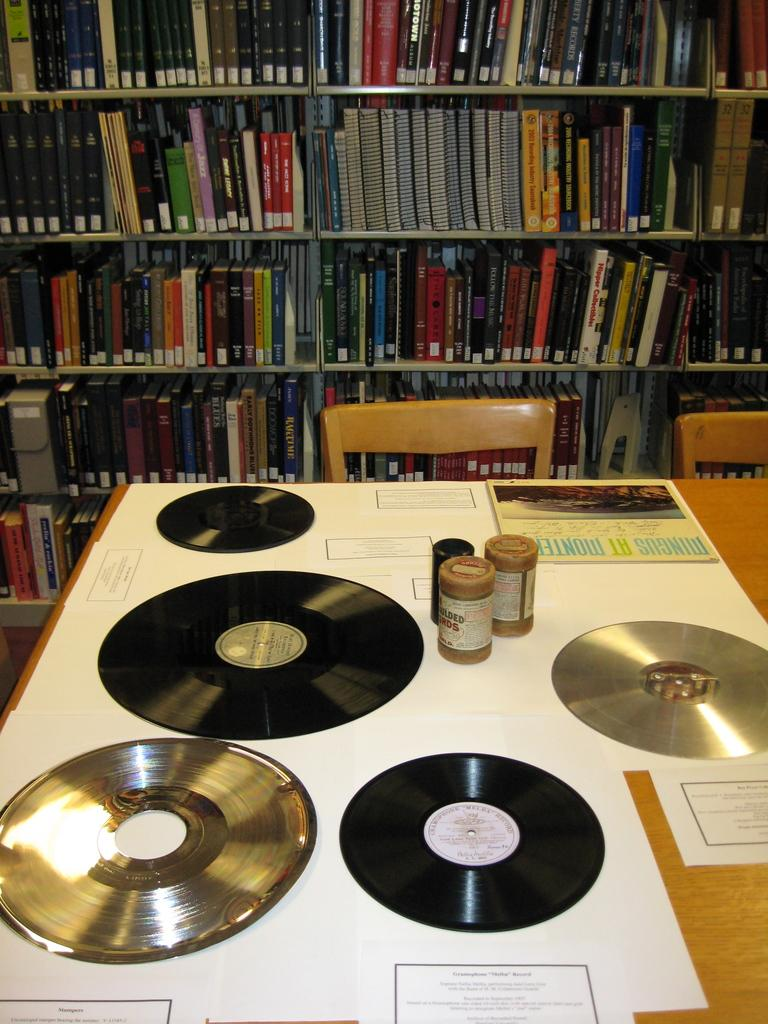What type of objects can be seen in the image? There are CDs in the image. Where are these objects located? The objects are on the table in the image. What type of furniture is visible in the image? There are chairs visible in the image. What is the purpose of the book-rack in the image? The book-rack is used to store books, as there are books inside the book-rack. Can you tell me how many umbrellas are hanging from the book-rack in the image? There are no umbrellas present in the image; the book-rack contains books. 